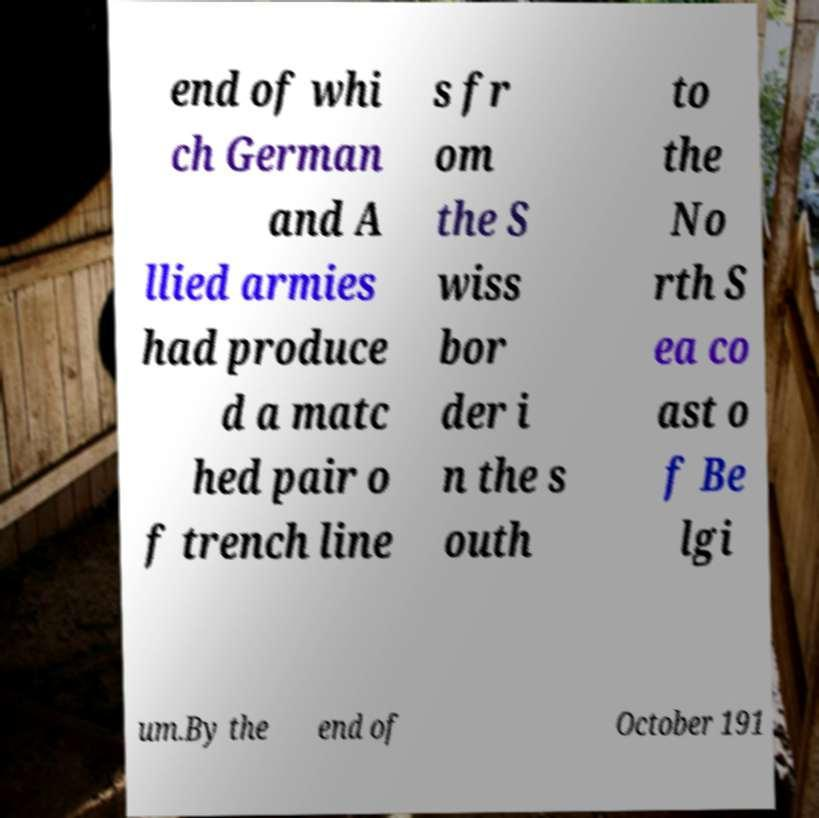I need the written content from this picture converted into text. Can you do that? end of whi ch German and A llied armies had produce d a matc hed pair o f trench line s fr om the S wiss bor der i n the s outh to the No rth S ea co ast o f Be lgi um.By the end of October 191 